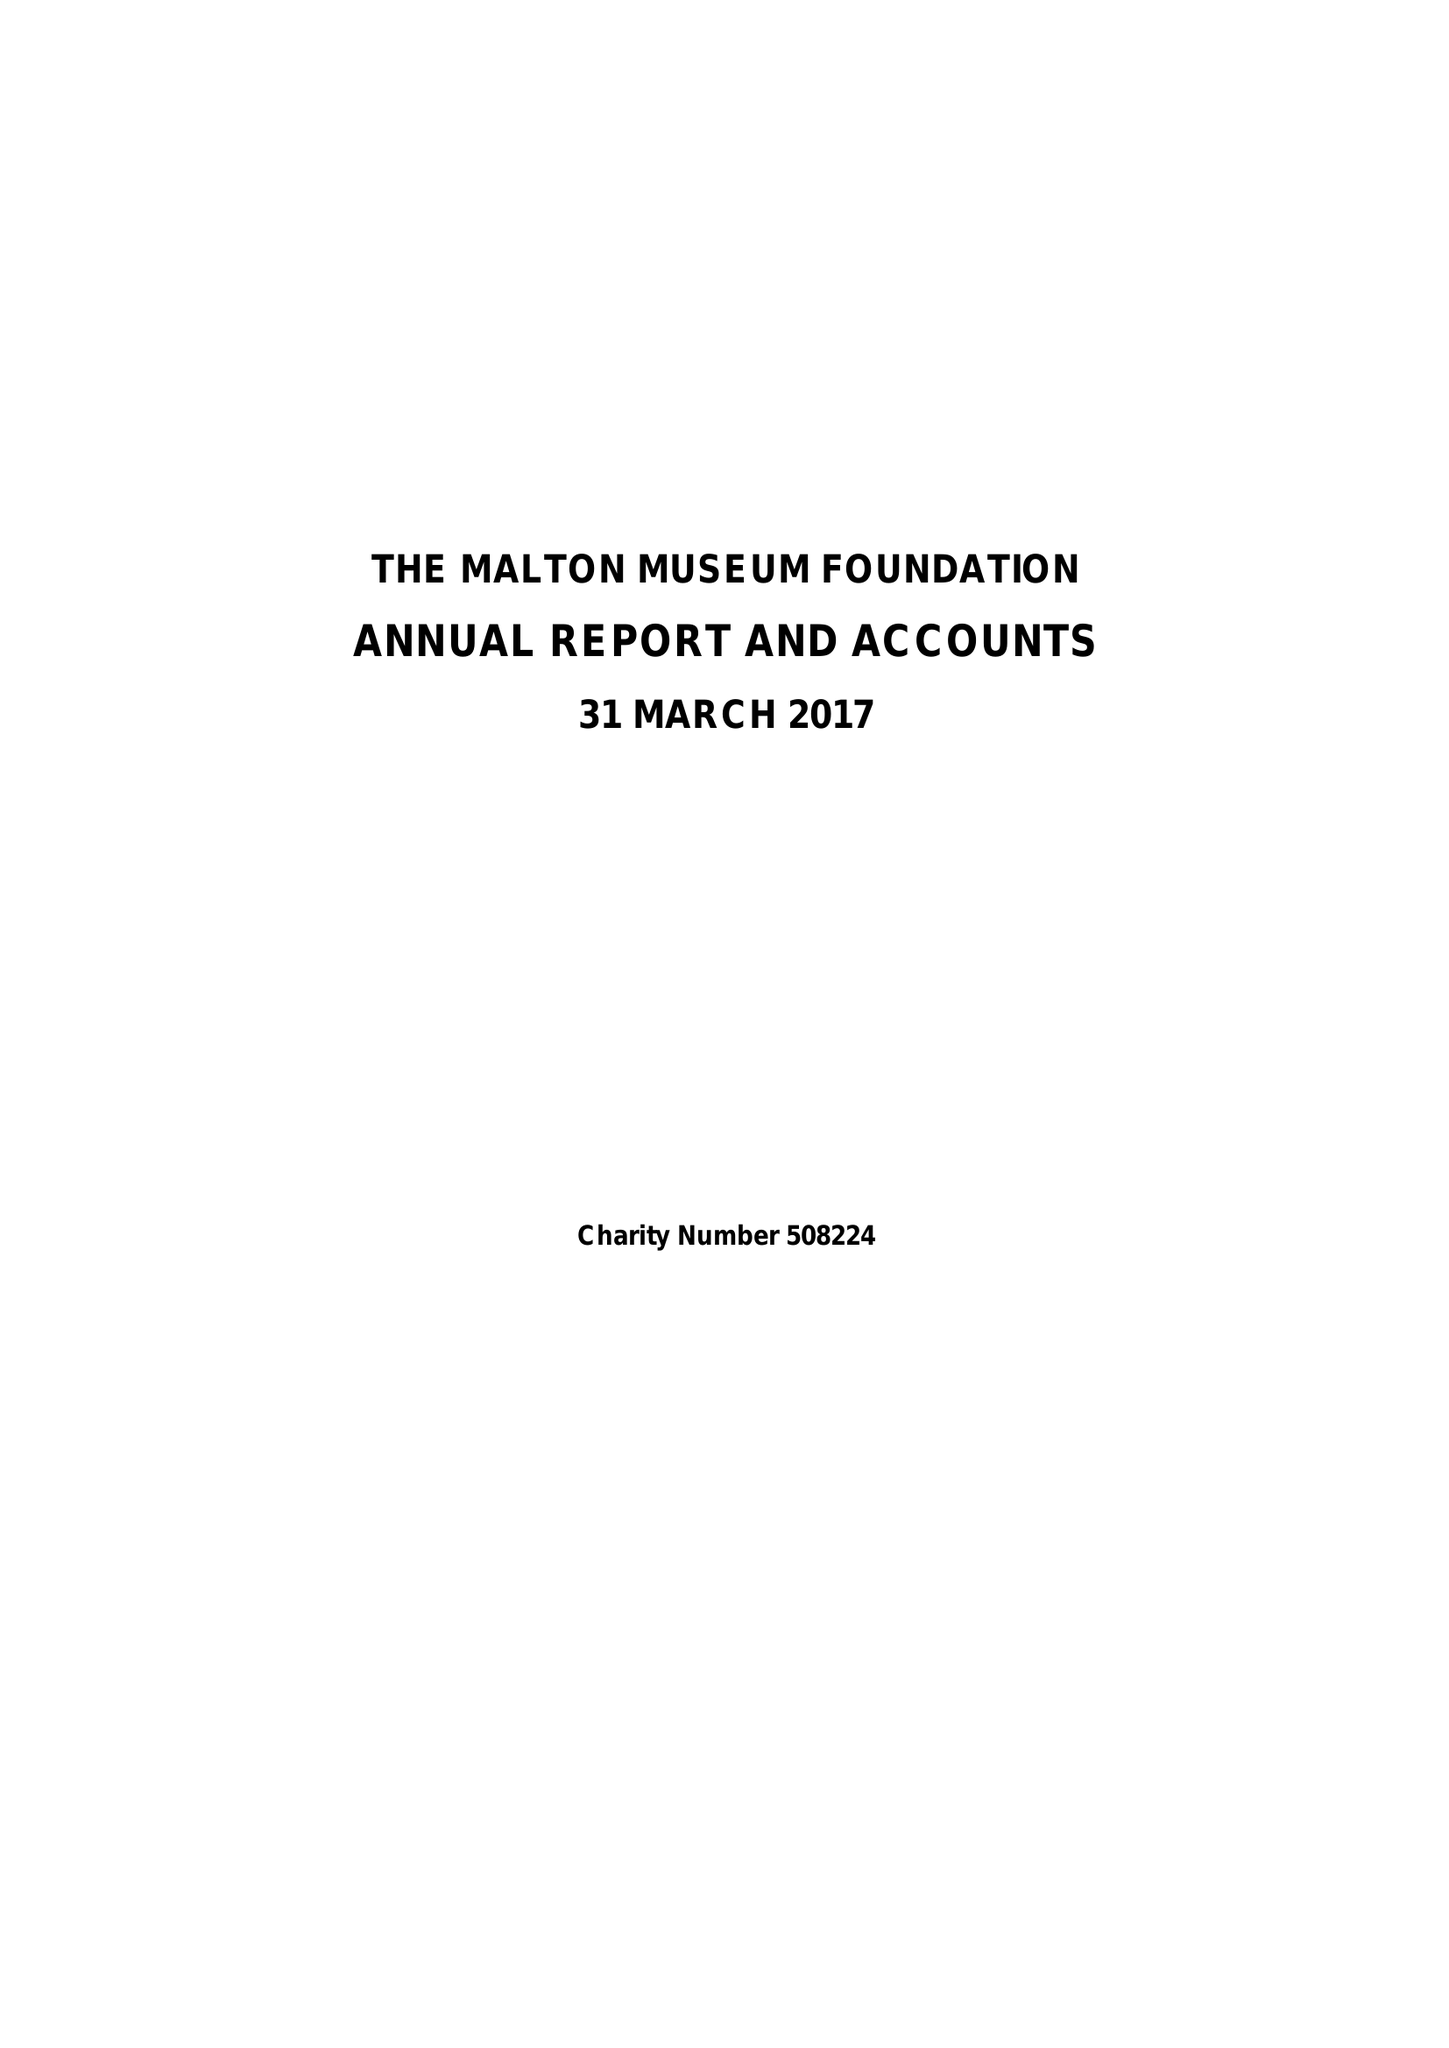What is the value for the address__street_line?
Answer the question using a single word or phrase. MAIN STREET 